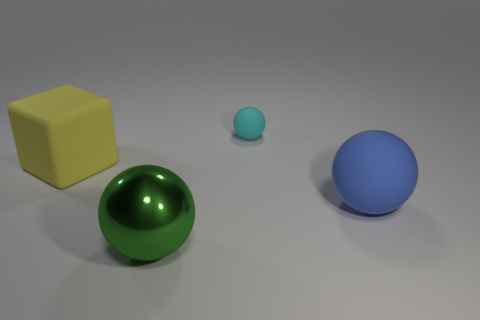Subtract all blue matte spheres. How many spheres are left? 2 Add 4 large green matte objects. How many objects exist? 8 Subtract all spheres. How many objects are left? 1 Subtract all yellow spheres. Subtract all cyan cylinders. How many spheres are left? 3 Subtract all large yellow rubber cylinders. Subtract all rubber objects. How many objects are left? 1 Add 4 green objects. How many green objects are left? 5 Add 3 green spheres. How many green spheres exist? 4 Subtract 0 brown blocks. How many objects are left? 4 